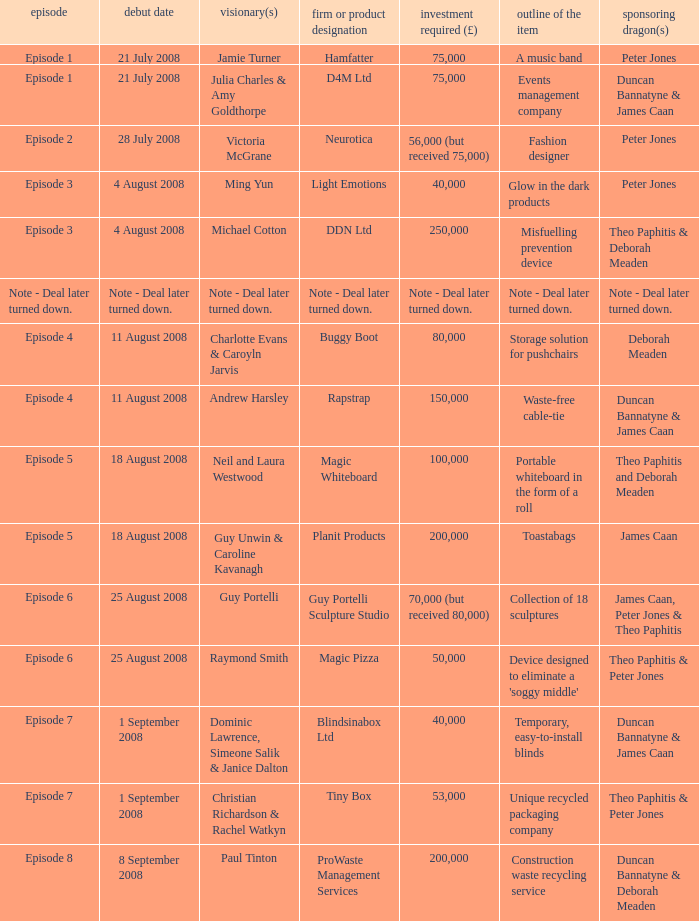When did episode 6 first air with entrepreneur Guy Portelli? 25 August 2008. 